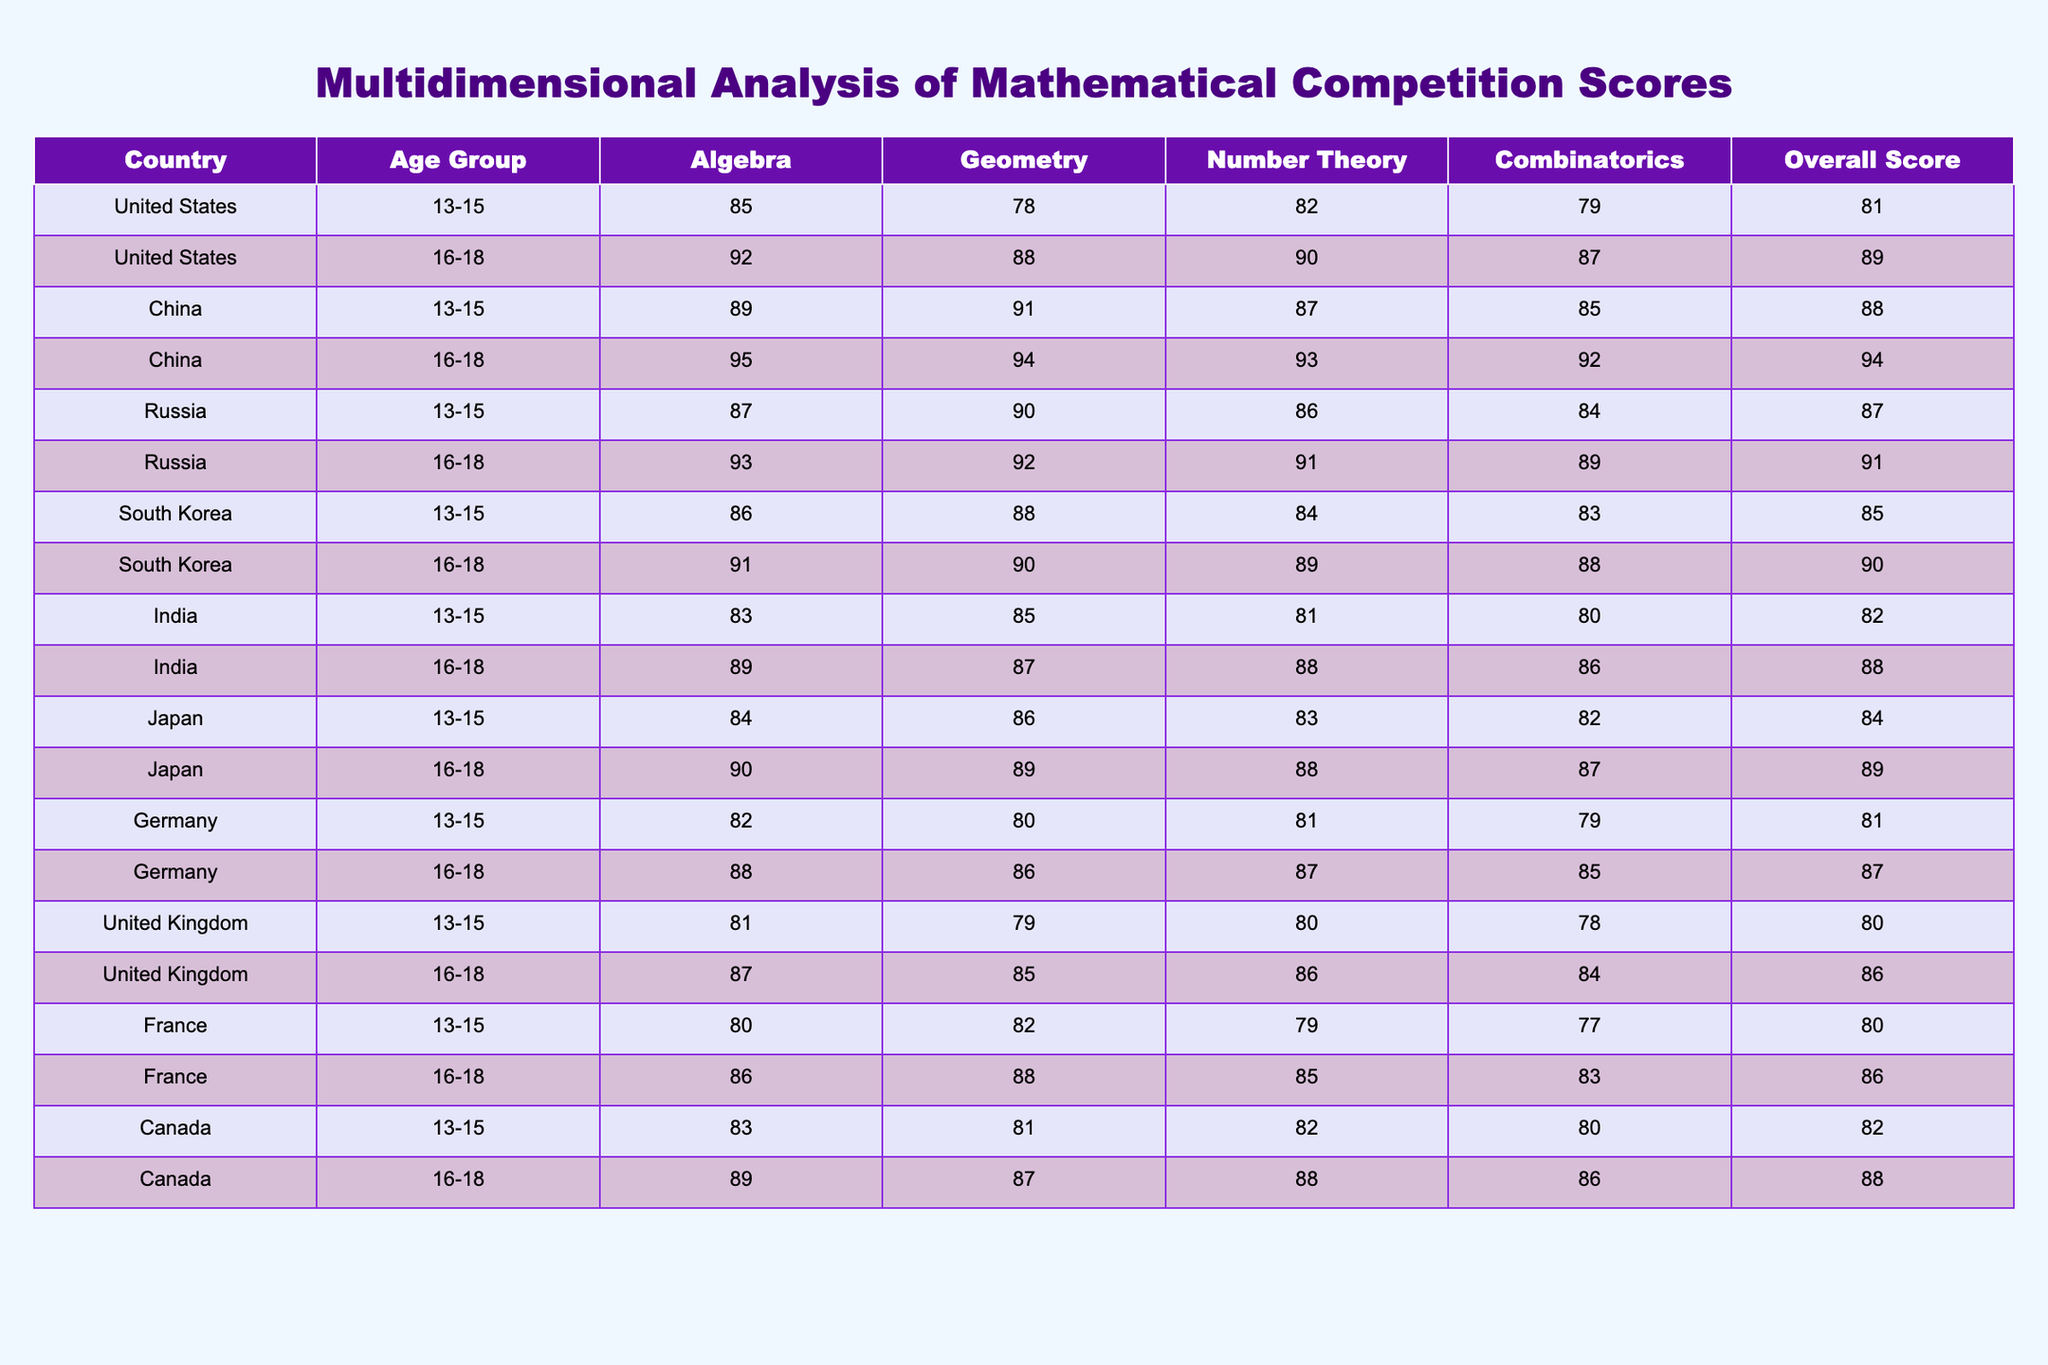What is the overall score of the 16-18 age group from China? The table shows the overall score for each age group and country. For China in the 16-18 age group, the overall score is listed as 94.
Answer: 94 Which country had the highest score in Algebra for the 13-15 age group? In the table, the scores for Algebra in the 13-15 age group are 85 for the United States, 89 for China, 87 for Russia, 86 for South Korea, 83 for India, 84 for Japan, 82 for Germany, 81 for the United Kingdom, 80 for France, and 83 for Canada. The highest score is 89 from China.
Answer: China What is the average overall score for the 16-18 age group across all countries? To find the average overall score, we take the sum of the overall scores for the 16-18 age group: 89 (US) + 94 (China) + 91 (Russia) + 90 (South Korea) + 88 (India) + 89 (Japan) + 87 (Germany) + 86 (UK) + 86 (France) + 88 (Canada) = 888. There are 10 scores, so the average is 888/10 = 88.8.
Answer: 88.8 Is the overall score for South Korea's 13-15 age group greater than that of India's 16-18 age group? The overall score for South Korea's 13-15 age group is 85, while India's 16-18 age group score is 88. Since 85 is less than 88, South Korea's score is not greater.
Answer: No What is the difference between the overall scores of the 16-18 age group in the United States and Germany? The overall score for the 16-18 age group in the United States is 89 and in Germany, it is 87. To find the difference: 89 - 87 = 2.
Answer: 2 Which country had the highest score in Geometry and what was that score? The scores in Geometry are 78 for the United States, 91 for China, 90 for Russia, 88 for South Korea, 85 for India, 89 for Japan, 80 for Germany, 79 for the United Kingdom, 82 for France, and 87 for Canada. The highest score is 91 from China.
Answer: China, 91 What can be concluded about the performance in Algebra for the 16-18 age group in the United States compared to Russia? The scores in Algebra for the 16-18 age group are 92 for the United States and 93 for Russia. Since the score for Russia is higher than that of the United States, we can conclude that Russia performed better in Algebra for this age group.
Answer: Russia performed better What is the highest overall score recorded among all age groups and countries? The overall scores are listed in the table, where the highest score observed is 94 for China in the 16-18 age group.
Answer: 94 Is there a persistent trend of higher scores in older age groups compared to younger age groups across all countries? By comparing the data points in the table, many countries show higher scores in the 16-18 age group versus the 13-15 age group but not universally. For countries like Germany and India, the overall scores for older individuals are slightly higher, while other countries maintain similar levels. Thus, it isn't consistent across all.
Answer: No What can be inferred about the performance in Combinatorics for Japan between the two age groups? For Japan, the Combinatorics scores are 82 for the 13-15 age group and 87 for the 16-18 age group. This shows an improvement of 5 points from the younger group to the older group.
Answer: Improved by 5 points 